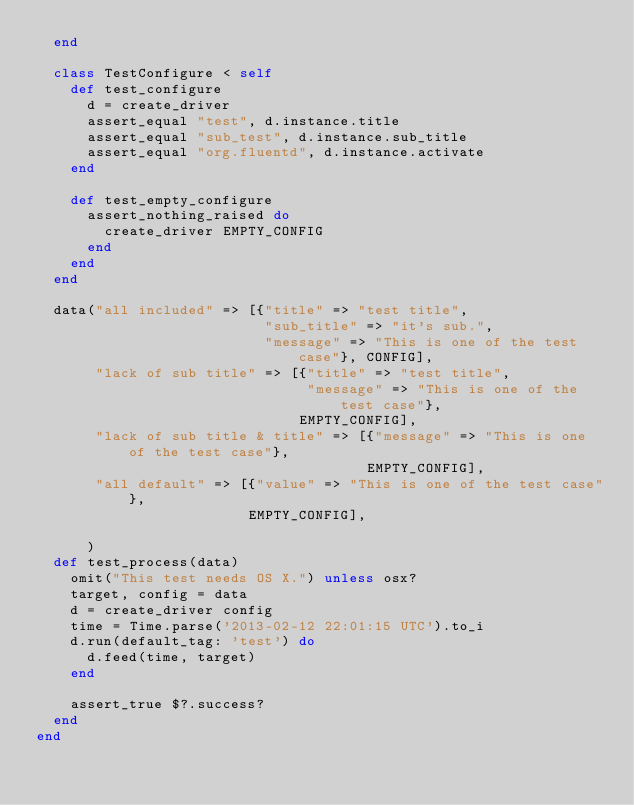<code> <loc_0><loc_0><loc_500><loc_500><_Ruby_>  end

  class TestConfigure < self
    def test_configure
      d = create_driver
      assert_equal "test", d.instance.title
      assert_equal "sub_test", d.instance.sub_title
      assert_equal "org.fluentd", d.instance.activate
    end

    def test_empty_configure
      assert_nothing_raised do
        create_driver EMPTY_CONFIG
      end
    end
  end

  data("all included" => [{"title" => "test title",
                           "sub_title" => "it's sub.",
                           "message" => "This is one of the test case"}, CONFIG],
       "lack of sub title" => [{"title" => "test title",
                                "message" => "This is one of the test case"},
                               EMPTY_CONFIG],
       "lack of sub title & title" => [{"message" => "This is one of the test case"},
                                       EMPTY_CONFIG],
       "all default" => [{"value" => "This is one of the test case"},
                         EMPTY_CONFIG],

      )
  def test_process(data)
    omit("This test needs OS X.") unless osx?
    target, config = data
    d = create_driver config
    time = Time.parse('2013-02-12 22:01:15 UTC').to_i
    d.run(default_tag: 'test') do
      d.feed(time, target)
    end

    assert_true $?.success?
  end
end
</code> 